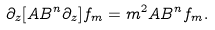<formula> <loc_0><loc_0><loc_500><loc_500>\partial _ { z } [ A B ^ { n } \partial _ { z } ] f _ { m } = m ^ { 2 } A B ^ { n } f _ { m } .</formula> 